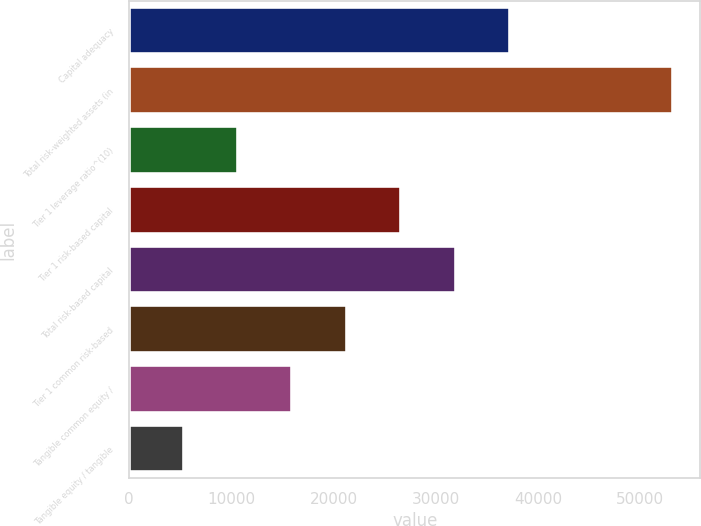Convert chart to OTSL. <chart><loc_0><loc_0><loc_500><loc_500><bar_chart><fcel>Capital adequacy<fcel>Total risk-weighted assets (in<fcel>Tier 1 leverage ratio^(10)<fcel>Tier 1 risk-based capital<fcel>Total risk-based capital<fcel>Tier 1 common risk-based<fcel>Tangible common equity /<fcel>Tangible equity / tangible<nl><fcel>37269.8<fcel>53239<fcel>10654.5<fcel>26623.7<fcel>31946.8<fcel>21300.6<fcel>15977.6<fcel>5331.42<nl></chart> 